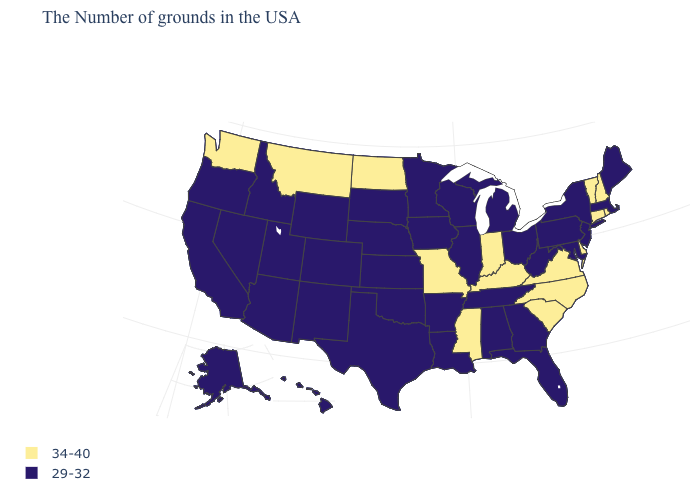Name the states that have a value in the range 29-32?
Quick response, please. Maine, Massachusetts, New York, New Jersey, Maryland, Pennsylvania, West Virginia, Ohio, Florida, Georgia, Michigan, Alabama, Tennessee, Wisconsin, Illinois, Louisiana, Arkansas, Minnesota, Iowa, Kansas, Nebraska, Oklahoma, Texas, South Dakota, Wyoming, Colorado, New Mexico, Utah, Arizona, Idaho, Nevada, California, Oregon, Alaska, Hawaii. Does the first symbol in the legend represent the smallest category?
Short answer required. No. Name the states that have a value in the range 29-32?
Short answer required. Maine, Massachusetts, New York, New Jersey, Maryland, Pennsylvania, West Virginia, Ohio, Florida, Georgia, Michigan, Alabama, Tennessee, Wisconsin, Illinois, Louisiana, Arkansas, Minnesota, Iowa, Kansas, Nebraska, Oklahoma, Texas, South Dakota, Wyoming, Colorado, New Mexico, Utah, Arizona, Idaho, Nevada, California, Oregon, Alaska, Hawaii. Which states have the lowest value in the MidWest?
Answer briefly. Ohio, Michigan, Wisconsin, Illinois, Minnesota, Iowa, Kansas, Nebraska, South Dakota. What is the lowest value in states that border New York?
Be succinct. 29-32. Does the map have missing data?
Be succinct. No. What is the value of Oregon?
Give a very brief answer. 29-32. Which states have the highest value in the USA?
Keep it brief. Rhode Island, New Hampshire, Vermont, Connecticut, Delaware, Virginia, North Carolina, South Carolina, Kentucky, Indiana, Mississippi, Missouri, North Dakota, Montana, Washington. Does South Dakota have the same value as New Hampshire?
Give a very brief answer. No. Name the states that have a value in the range 34-40?
Short answer required. Rhode Island, New Hampshire, Vermont, Connecticut, Delaware, Virginia, North Carolina, South Carolina, Kentucky, Indiana, Mississippi, Missouri, North Dakota, Montana, Washington. Which states have the highest value in the USA?
Short answer required. Rhode Island, New Hampshire, Vermont, Connecticut, Delaware, Virginia, North Carolina, South Carolina, Kentucky, Indiana, Mississippi, Missouri, North Dakota, Montana, Washington. Is the legend a continuous bar?
Answer briefly. No. What is the lowest value in the USA?
Answer briefly. 29-32. What is the highest value in the MidWest ?
Be succinct. 34-40. What is the value of Missouri?
Keep it brief. 34-40. 